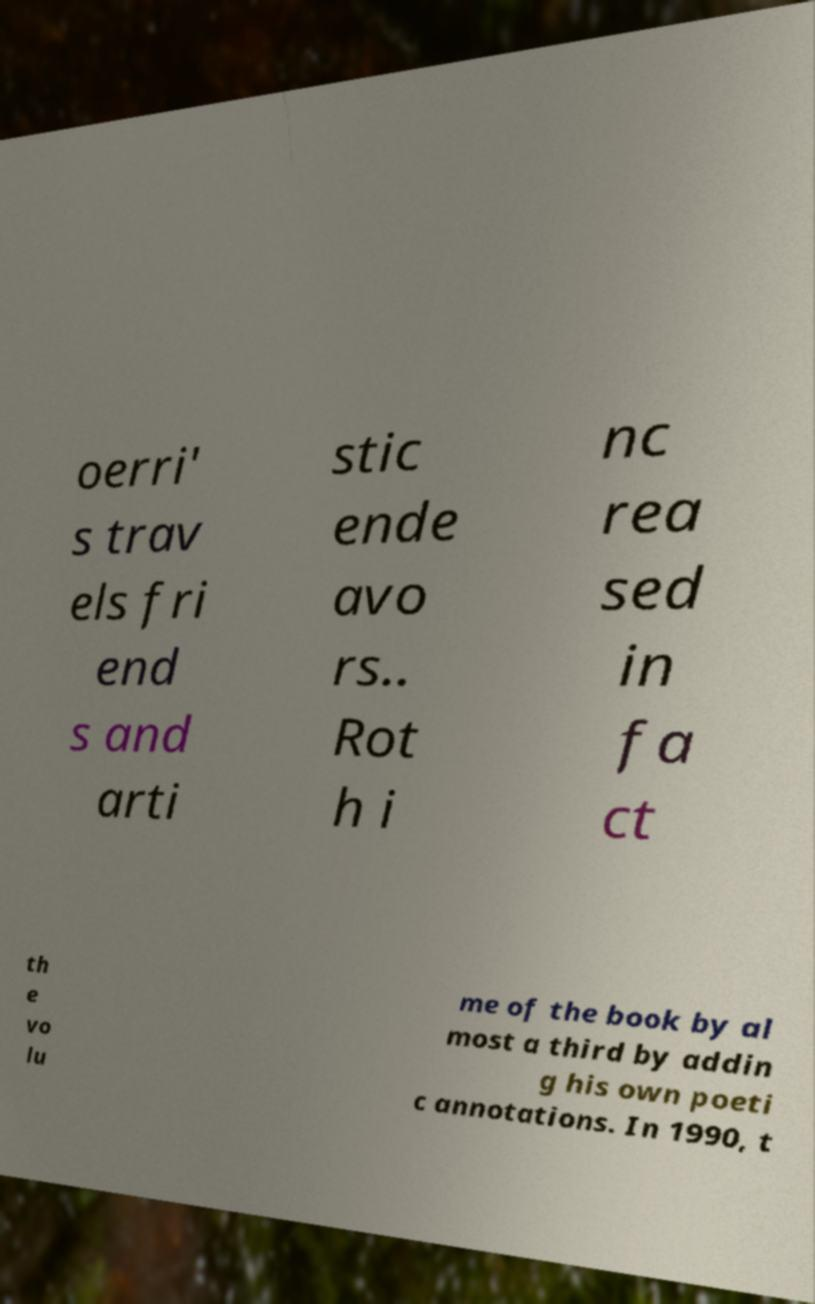I need the written content from this picture converted into text. Can you do that? oerri' s trav els fri end s and arti stic ende avo rs.. Rot h i nc rea sed in fa ct th e vo lu me of the book by al most a third by addin g his own poeti c annotations. In 1990, t 